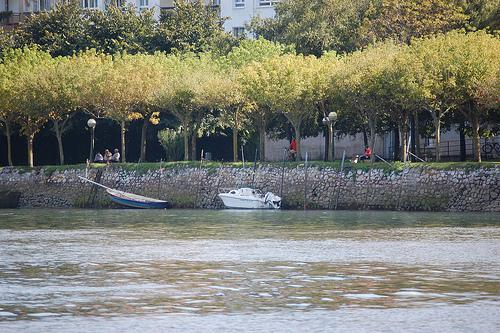Question: what color is the big boat?
Choices:
A. Blue.
B. Red.
C. Black.
D. White.
Answer with the letter. Answer: D Question: what are the boats on?
Choices:
A. Ice.
B. Mud.
C. Sand.
D. Water.
Answer with the letter. Answer: D Question: what type of wall is beside the boats?
Choices:
A. Brick.
B. Plaster.
C. Wood.
D. Stone.
Answer with the letter. Answer: D Question: where is this shot?
Choices:
A. Ocean.
B. Pool.
C. River.
D. Bathtub.
Answer with the letter. Answer: C Question: when was this taken?
Choices:
A. Night.
B. Sunset.
C. Daytime.
D. New Year's Day.
Answer with the letter. Answer: C Question: how many people are shown?
Choices:
A. 8.
B. 5.
C. 2.
D. 10.
Answer with the letter. Answer: B Question: how many animals are there?
Choices:
A. 2.
B. 5.
C. 0.
D. 7.
Answer with the letter. Answer: C 